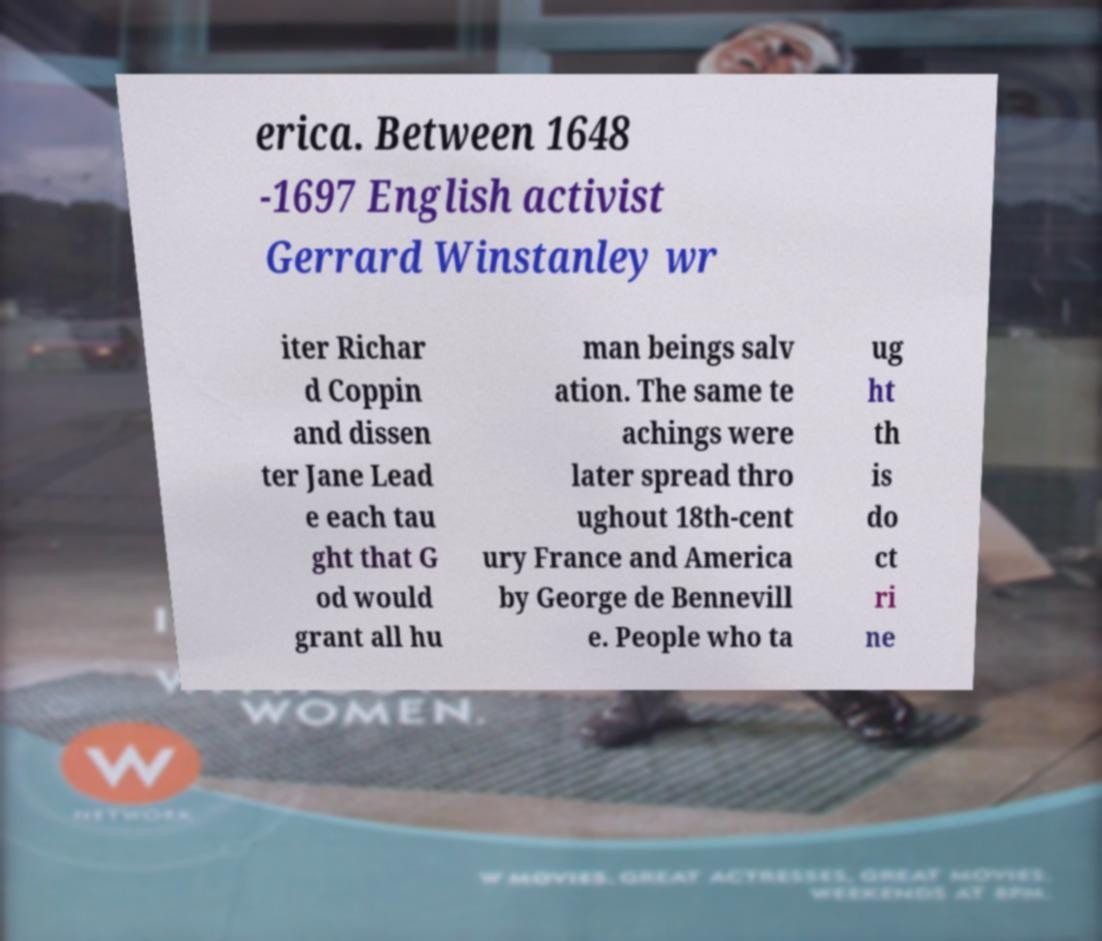Could you extract and type out the text from this image? erica. Between 1648 -1697 English activist Gerrard Winstanley wr iter Richar d Coppin and dissen ter Jane Lead e each tau ght that G od would grant all hu man beings salv ation. The same te achings were later spread thro ughout 18th-cent ury France and America by George de Bennevill e. People who ta ug ht th is do ct ri ne 